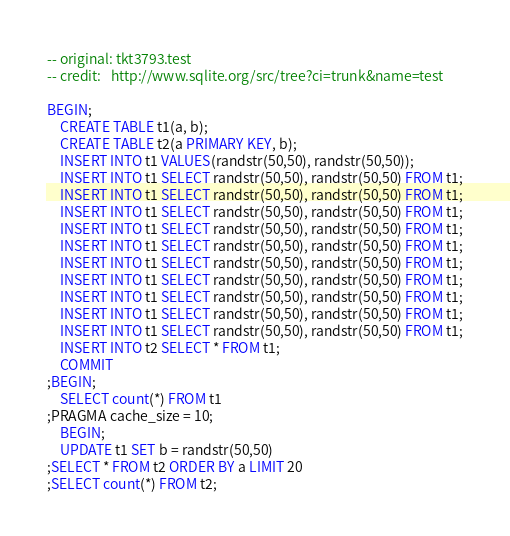Convert code to text. <code><loc_0><loc_0><loc_500><loc_500><_SQL_>-- original: tkt3793.test
-- credit:   http://www.sqlite.org/src/tree?ci=trunk&name=test

BEGIN;
    CREATE TABLE t1(a, b);
    CREATE TABLE t2(a PRIMARY KEY, b);
    INSERT INTO t1 VALUES(randstr(50,50), randstr(50,50));
    INSERT INTO t1 SELECT randstr(50,50), randstr(50,50) FROM t1;
    INSERT INTO t1 SELECT randstr(50,50), randstr(50,50) FROM t1;
    INSERT INTO t1 SELECT randstr(50,50), randstr(50,50) FROM t1;
    INSERT INTO t1 SELECT randstr(50,50), randstr(50,50) FROM t1;
    INSERT INTO t1 SELECT randstr(50,50), randstr(50,50) FROM t1;
    INSERT INTO t1 SELECT randstr(50,50), randstr(50,50) FROM t1;
    INSERT INTO t1 SELECT randstr(50,50), randstr(50,50) FROM t1;
    INSERT INTO t1 SELECT randstr(50,50), randstr(50,50) FROM t1;
    INSERT INTO t1 SELECT randstr(50,50), randstr(50,50) FROM t1;
    INSERT INTO t1 SELECT randstr(50,50), randstr(50,50) FROM t1;
    INSERT INTO t2 SELECT * FROM t1;
    COMMIT
;BEGIN;
    SELECT count(*) FROM t1
;PRAGMA cache_size = 10;
    BEGIN;
    UPDATE t1 SET b = randstr(50,50)
;SELECT * FROM t2 ORDER BY a LIMIT 20
;SELECT count(*) FROM t2;</code> 